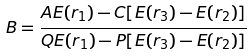Convert formula to latex. <formula><loc_0><loc_0><loc_500><loc_500>B = \frac { A E ( r _ { 1 } ) - C [ E ( r _ { 3 } ) - E ( r _ { 2 } ) ] } { Q E ( r _ { 1 } ) - P [ E ( r _ { 3 } ) - E ( r _ { 2 } ) ] }</formula> 